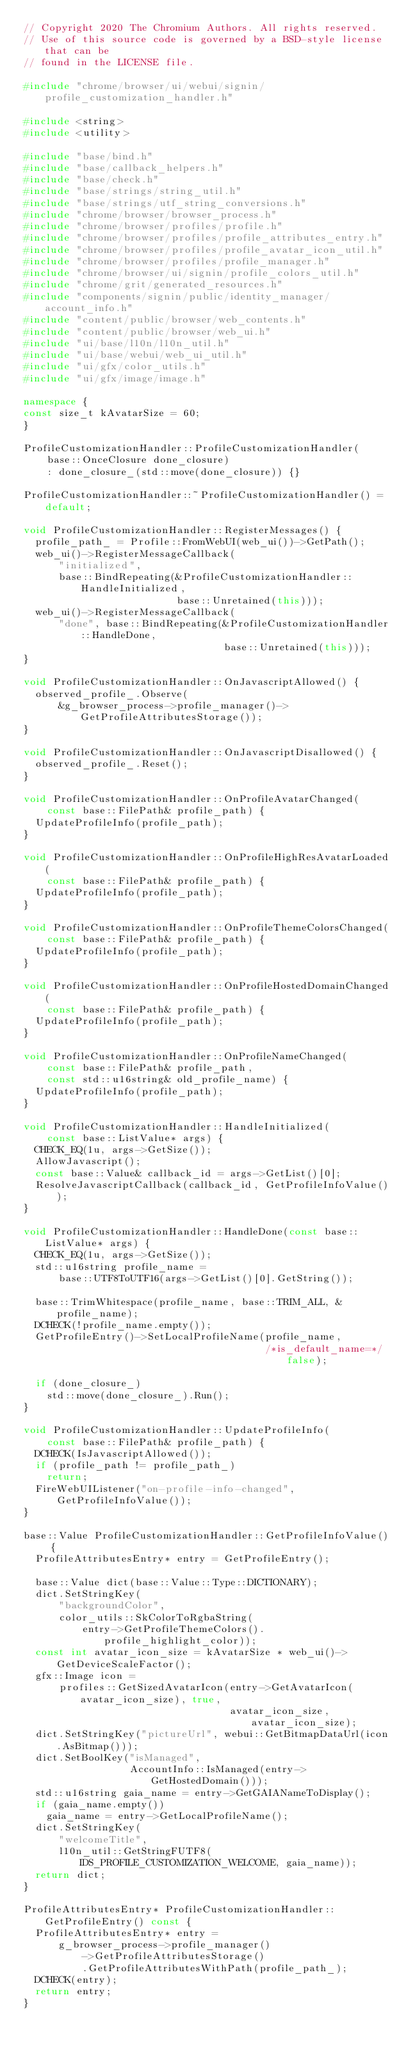<code> <loc_0><loc_0><loc_500><loc_500><_C++_>// Copyright 2020 The Chromium Authors. All rights reserved.
// Use of this source code is governed by a BSD-style license that can be
// found in the LICENSE file.

#include "chrome/browser/ui/webui/signin/profile_customization_handler.h"

#include <string>
#include <utility>

#include "base/bind.h"
#include "base/callback_helpers.h"
#include "base/check.h"
#include "base/strings/string_util.h"
#include "base/strings/utf_string_conversions.h"
#include "chrome/browser/browser_process.h"
#include "chrome/browser/profiles/profile.h"
#include "chrome/browser/profiles/profile_attributes_entry.h"
#include "chrome/browser/profiles/profile_avatar_icon_util.h"
#include "chrome/browser/profiles/profile_manager.h"
#include "chrome/browser/ui/signin/profile_colors_util.h"
#include "chrome/grit/generated_resources.h"
#include "components/signin/public/identity_manager/account_info.h"
#include "content/public/browser/web_contents.h"
#include "content/public/browser/web_ui.h"
#include "ui/base/l10n/l10n_util.h"
#include "ui/base/webui/web_ui_util.h"
#include "ui/gfx/color_utils.h"
#include "ui/gfx/image/image.h"

namespace {
const size_t kAvatarSize = 60;
}

ProfileCustomizationHandler::ProfileCustomizationHandler(
    base::OnceClosure done_closure)
    : done_closure_(std::move(done_closure)) {}

ProfileCustomizationHandler::~ProfileCustomizationHandler() = default;

void ProfileCustomizationHandler::RegisterMessages() {
  profile_path_ = Profile::FromWebUI(web_ui())->GetPath();
  web_ui()->RegisterMessageCallback(
      "initialized",
      base::BindRepeating(&ProfileCustomizationHandler::HandleInitialized,
                          base::Unretained(this)));
  web_ui()->RegisterMessageCallback(
      "done", base::BindRepeating(&ProfileCustomizationHandler::HandleDone,
                                  base::Unretained(this)));
}

void ProfileCustomizationHandler::OnJavascriptAllowed() {
  observed_profile_.Observe(
      &g_browser_process->profile_manager()->GetProfileAttributesStorage());
}

void ProfileCustomizationHandler::OnJavascriptDisallowed() {
  observed_profile_.Reset();
}

void ProfileCustomizationHandler::OnProfileAvatarChanged(
    const base::FilePath& profile_path) {
  UpdateProfileInfo(profile_path);
}

void ProfileCustomizationHandler::OnProfileHighResAvatarLoaded(
    const base::FilePath& profile_path) {
  UpdateProfileInfo(profile_path);
}

void ProfileCustomizationHandler::OnProfileThemeColorsChanged(
    const base::FilePath& profile_path) {
  UpdateProfileInfo(profile_path);
}

void ProfileCustomizationHandler::OnProfileHostedDomainChanged(
    const base::FilePath& profile_path) {
  UpdateProfileInfo(profile_path);
}

void ProfileCustomizationHandler::OnProfileNameChanged(
    const base::FilePath& profile_path,
    const std::u16string& old_profile_name) {
  UpdateProfileInfo(profile_path);
}

void ProfileCustomizationHandler::HandleInitialized(
    const base::ListValue* args) {
  CHECK_EQ(1u, args->GetSize());
  AllowJavascript();
  const base::Value& callback_id = args->GetList()[0];
  ResolveJavascriptCallback(callback_id, GetProfileInfoValue());
}

void ProfileCustomizationHandler::HandleDone(const base::ListValue* args) {
  CHECK_EQ(1u, args->GetSize());
  std::u16string profile_name =
      base::UTF8ToUTF16(args->GetList()[0].GetString());

  base::TrimWhitespace(profile_name, base::TRIM_ALL, &profile_name);
  DCHECK(!profile_name.empty());
  GetProfileEntry()->SetLocalProfileName(profile_name,
                                         /*is_default_name=*/false);

  if (done_closure_)
    std::move(done_closure_).Run();
}

void ProfileCustomizationHandler::UpdateProfileInfo(
    const base::FilePath& profile_path) {
  DCHECK(IsJavascriptAllowed());
  if (profile_path != profile_path_)
    return;
  FireWebUIListener("on-profile-info-changed", GetProfileInfoValue());
}

base::Value ProfileCustomizationHandler::GetProfileInfoValue() {
  ProfileAttributesEntry* entry = GetProfileEntry();

  base::Value dict(base::Value::Type::DICTIONARY);
  dict.SetStringKey(
      "backgroundColor",
      color_utils::SkColorToRgbaString(
          entry->GetProfileThemeColors().profile_highlight_color));
  const int avatar_icon_size = kAvatarSize * web_ui()->GetDeviceScaleFactor();
  gfx::Image icon =
      profiles::GetSizedAvatarIcon(entry->GetAvatarIcon(avatar_icon_size), true,
                                   avatar_icon_size, avatar_icon_size);
  dict.SetStringKey("pictureUrl", webui::GetBitmapDataUrl(icon.AsBitmap()));
  dict.SetBoolKey("isManaged",
                  AccountInfo::IsManaged(entry->GetHostedDomain()));
  std::u16string gaia_name = entry->GetGAIANameToDisplay();
  if (gaia_name.empty())
    gaia_name = entry->GetLocalProfileName();
  dict.SetStringKey(
      "welcomeTitle",
      l10n_util::GetStringFUTF8(IDS_PROFILE_CUSTOMIZATION_WELCOME, gaia_name));
  return dict;
}

ProfileAttributesEntry* ProfileCustomizationHandler::GetProfileEntry() const {
  ProfileAttributesEntry* entry =
      g_browser_process->profile_manager()
          ->GetProfileAttributesStorage()
          .GetProfileAttributesWithPath(profile_path_);
  DCHECK(entry);
  return entry;
}
</code> 